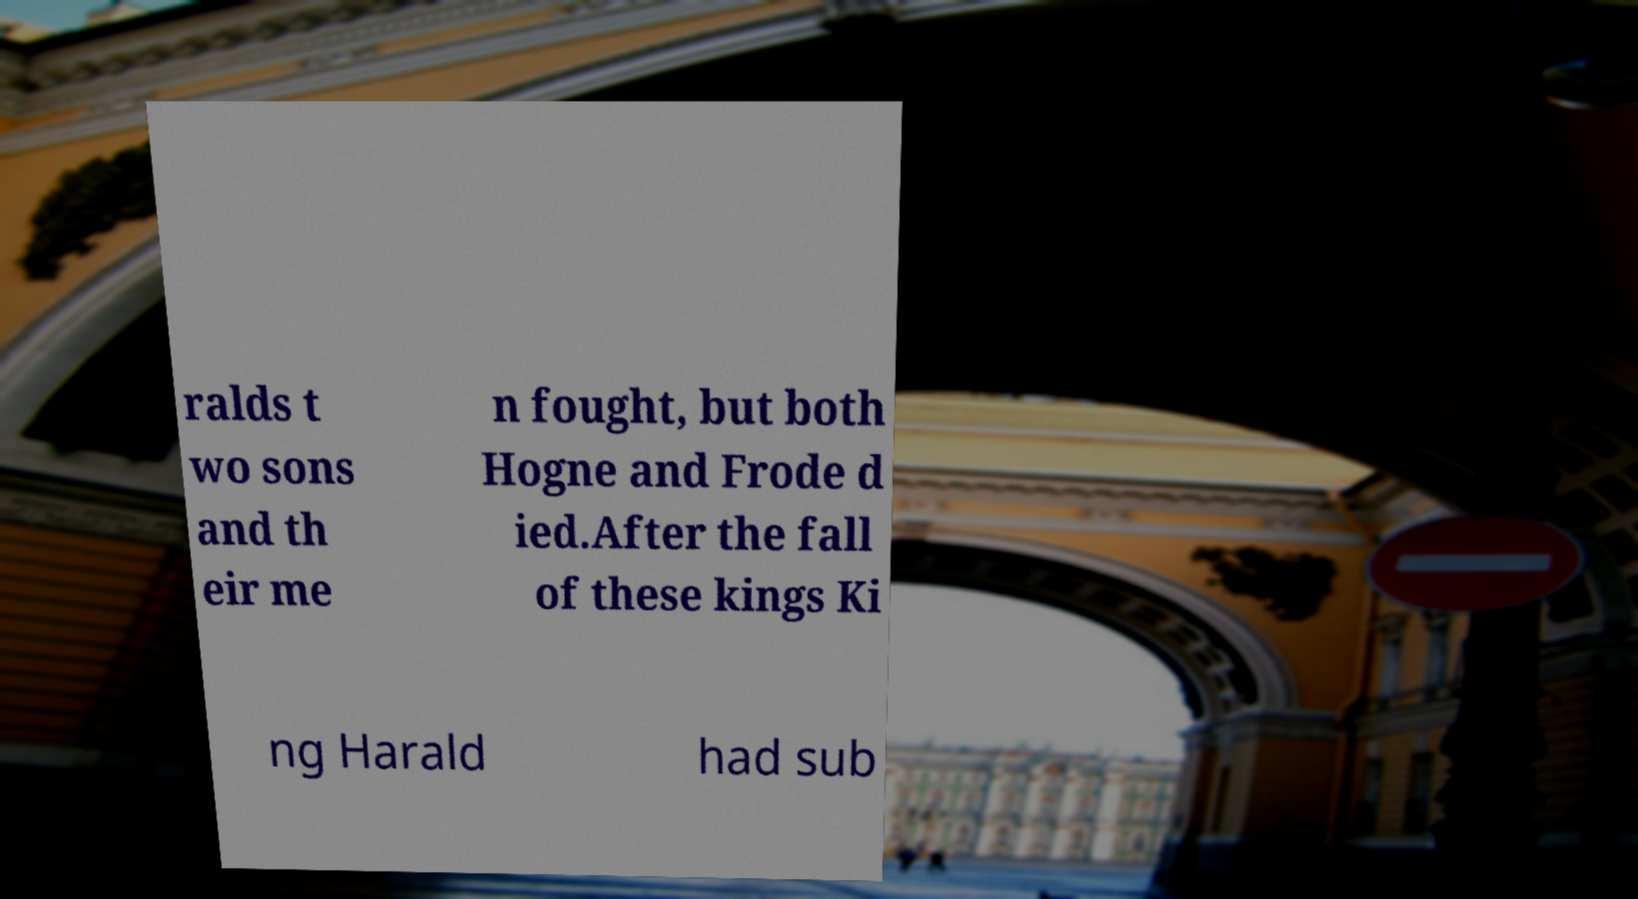Could you assist in decoding the text presented in this image and type it out clearly? ralds t wo sons and th eir me n fought, but both Hogne and Frode d ied.After the fall of these kings Ki ng Harald had sub 